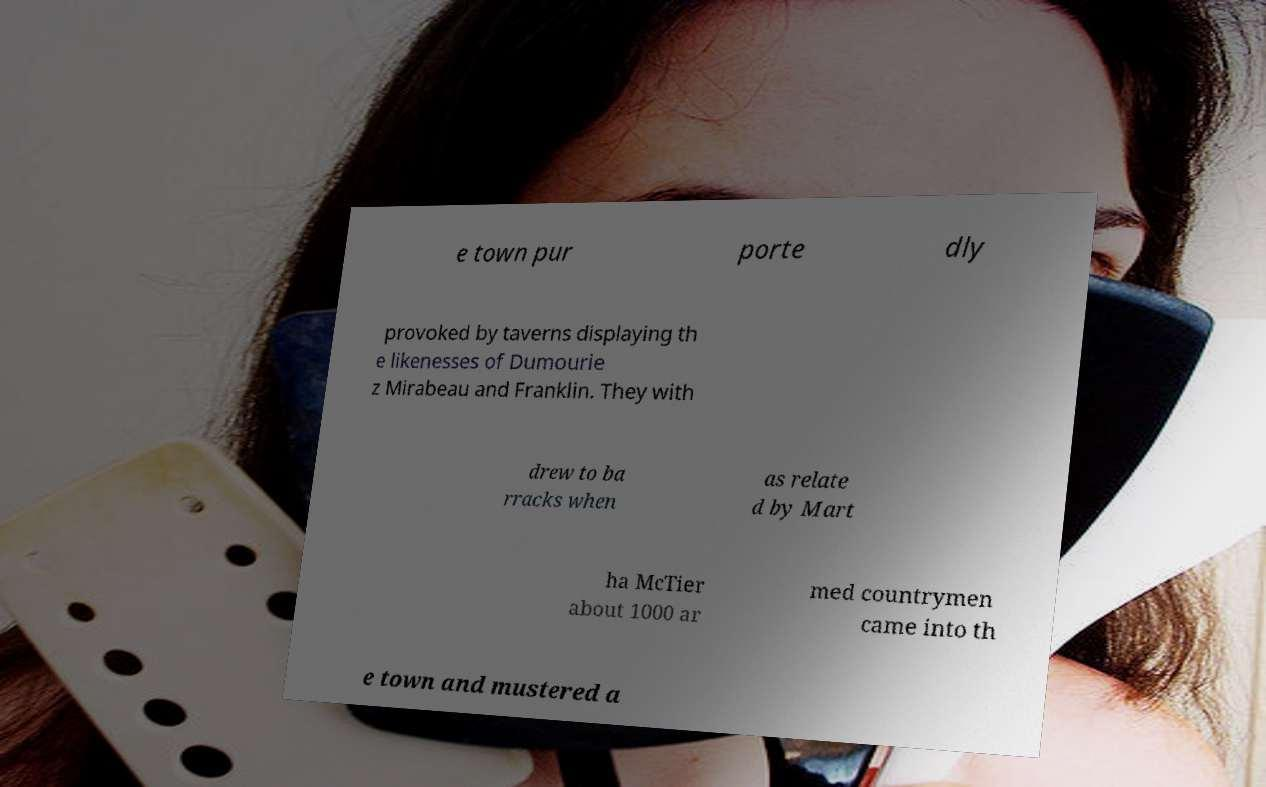For documentation purposes, I need the text within this image transcribed. Could you provide that? e town pur porte dly provoked by taverns displaying th e likenesses of Dumourie z Mirabeau and Franklin. They with drew to ba rracks when as relate d by Mart ha McTier about 1000 ar med countrymen came into th e town and mustered a 